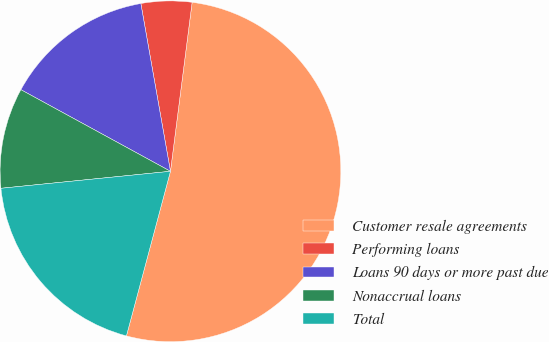Convert chart. <chart><loc_0><loc_0><loc_500><loc_500><pie_chart><fcel>Customer resale agreements<fcel>Performing loans<fcel>Loans 90 days or more past due<fcel>Nonaccrual loans<fcel>Total<nl><fcel>52.13%<fcel>4.81%<fcel>14.27%<fcel>9.54%<fcel>19.25%<nl></chart> 